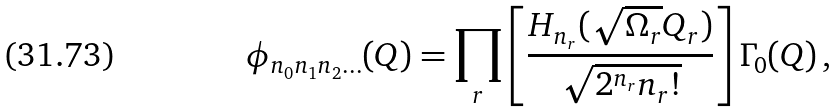Convert formula to latex. <formula><loc_0><loc_0><loc_500><loc_500>\phi _ { n _ { 0 } n _ { 1 } n _ { 2 } \dots } ( Q ) = \prod _ { r } \left [ \frac { H _ { n _ { r } } ( \sqrt { \Omega _ { r } } Q _ { r } ) } { \sqrt { 2 ^ { n _ { r } } n _ { r } ! } } \right ] \Gamma _ { 0 } ( Q ) \, ,</formula> 